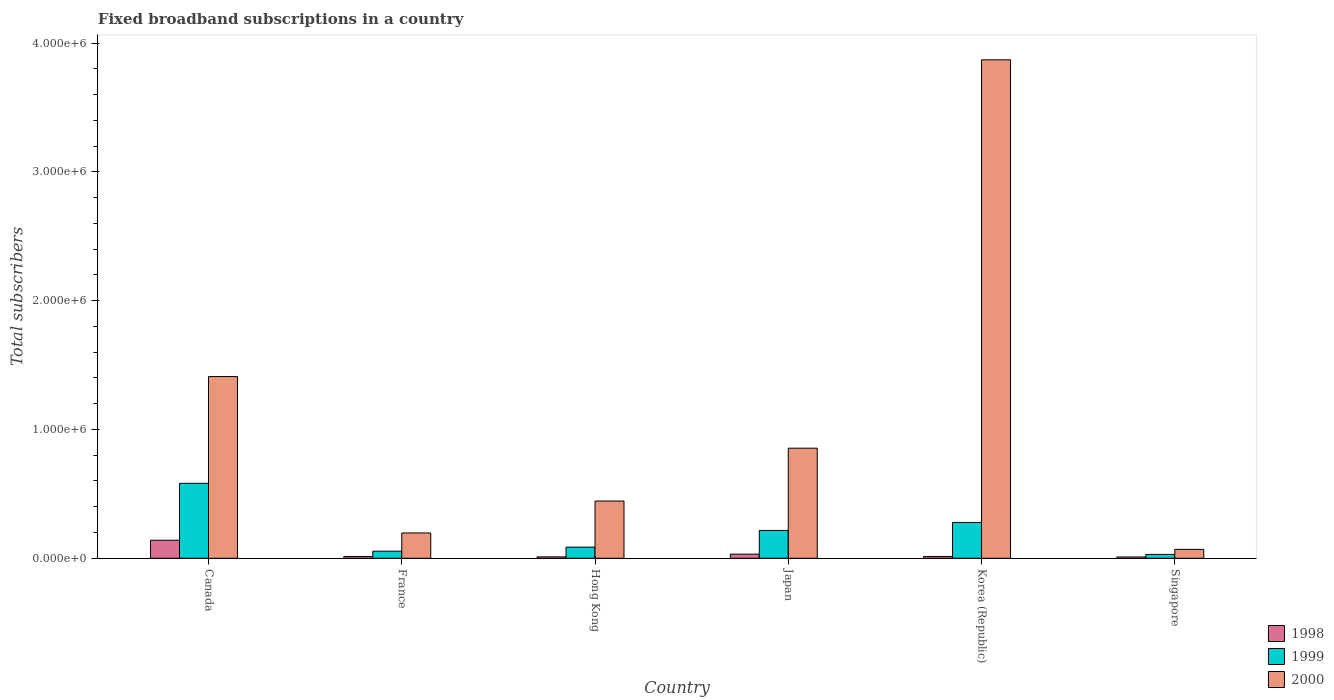How many groups of bars are there?
Your response must be concise. 6. Are the number of bars per tick equal to the number of legend labels?
Offer a terse response. Yes. Are the number of bars on each tick of the X-axis equal?
Your answer should be compact. Yes. How many bars are there on the 6th tick from the left?
Provide a short and direct response. 3. How many bars are there on the 4th tick from the right?
Provide a short and direct response. 3. What is the label of the 3rd group of bars from the left?
Offer a terse response. Hong Kong. What is the number of broadband subscriptions in 2000 in Korea (Republic)?
Offer a terse response. 3.87e+06. Across all countries, what is the maximum number of broadband subscriptions in 1999?
Keep it short and to the point. 5.82e+05. In which country was the number of broadband subscriptions in 2000 minimum?
Ensure brevity in your answer.  Singapore. What is the total number of broadband subscriptions in 1998 in the graph?
Ensure brevity in your answer.  2.20e+05. What is the difference between the number of broadband subscriptions in 1999 in Canada and that in Korea (Republic)?
Make the answer very short. 3.04e+05. What is the difference between the number of broadband subscriptions in 1999 in France and the number of broadband subscriptions in 1998 in Hong Kong?
Offer a terse response. 4.40e+04. What is the average number of broadband subscriptions in 1998 per country?
Your answer should be very brief. 3.67e+04. What is the difference between the number of broadband subscriptions of/in 1998 and number of broadband subscriptions of/in 2000 in Korea (Republic)?
Provide a succinct answer. -3.86e+06. In how many countries, is the number of broadband subscriptions in 1999 greater than 3400000?
Your answer should be compact. 0. What is the ratio of the number of broadband subscriptions in 1998 in France to that in Japan?
Ensure brevity in your answer.  0.42. Is the number of broadband subscriptions in 1999 in Canada less than that in France?
Provide a short and direct response. No. Is the difference between the number of broadband subscriptions in 1998 in Canada and Korea (Republic) greater than the difference between the number of broadband subscriptions in 2000 in Canada and Korea (Republic)?
Your answer should be compact. Yes. What is the difference between the highest and the second highest number of broadband subscriptions in 2000?
Offer a very short reply. 2.46e+06. What is the difference between the highest and the lowest number of broadband subscriptions in 1999?
Offer a very short reply. 5.52e+05. In how many countries, is the number of broadband subscriptions in 2000 greater than the average number of broadband subscriptions in 2000 taken over all countries?
Provide a short and direct response. 2. What does the 1st bar from the left in Singapore represents?
Offer a terse response. 1998. Are the values on the major ticks of Y-axis written in scientific E-notation?
Your response must be concise. Yes. Does the graph contain any zero values?
Your answer should be very brief. No. Does the graph contain grids?
Provide a short and direct response. No. How many legend labels are there?
Your answer should be very brief. 3. How are the legend labels stacked?
Keep it short and to the point. Vertical. What is the title of the graph?
Keep it short and to the point. Fixed broadband subscriptions in a country. What is the label or title of the Y-axis?
Offer a very short reply. Total subscribers. What is the Total subscribers of 1999 in Canada?
Your response must be concise. 5.82e+05. What is the Total subscribers of 2000 in Canada?
Your response must be concise. 1.41e+06. What is the Total subscribers of 1998 in France?
Make the answer very short. 1.35e+04. What is the Total subscribers in 1999 in France?
Offer a terse response. 5.50e+04. What is the Total subscribers in 2000 in France?
Your answer should be compact. 1.97e+05. What is the Total subscribers in 1998 in Hong Kong?
Your answer should be compact. 1.10e+04. What is the Total subscribers in 1999 in Hong Kong?
Offer a terse response. 8.65e+04. What is the Total subscribers in 2000 in Hong Kong?
Ensure brevity in your answer.  4.44e+05. What is the Total subscribers in 1998 in Japan?
Provide a succinct answer. 3.20e+04. What is the Total subscribers of 1999 in Japan?
Your answer should be very brief. 2.16e+05. What is the Total subscribers in 2000 in Japan?
Offer a very short reply. 8.55e+05. What is the Total subscribers of 1998 in Korea (Republic)?
Offer a very short reply. 1.40e+04. What is the Total subscribers in 1999 in Korea (Republic)?
Give a very brief answer. 2.78e+05. What is the Total subscribers of 2000 in Korea (Republic)?
Keep it short and to the point. 3.87e+06. What is the Total subscribers of 1999 in Singapore?
Your answer should be very brief. 3.00e+04. What is the Total subscribers in 2000 in Singapore?
Keep it short and to the point. 6.90e+04. Across all countries, what is the maximum Total subscribers of 1998?
Provide a short and direct response. 1.40e+05. Across all countries, what is the maximum Total subscribers of 1999?
Provide a short and direct response. 5.82e+05. Across all countries, what is the maximum Total subscribers in 2000?
Make the answer very short. 3.87e+06. Across all countries, what is the minimum Total subscribers of 2000?
Ensure brevity in your answer.  6.90e+04. What is the total Total subscribers of 1998 in the graph?
Provide a succinct answer. 2.20e+05. What is the total Total subscribers in 1999 in the graph?
Offer a very short reply. 1.25e+06. What is the total Total subscribers of 2000 in the graph?
Your answer should be very brief. 6.85e+06. What is the difference between the Total subscribers of 1998 in Canada and that in France?
Give a very brief answer. 1.27e+05. What is the difference between the Total subscribers of 1999 in Canada and that in France?
Give a very brief answer. 5.27e+05. What is the difference between the Total subscribers in 2000 in Canada and that in France?
Ensure brevity in your answer.  1.21e+06. What is the difference between the Total subscribers of 1998 in Canada and that in Hong Kong?
Provide a succinct answer. 1.29e+05. What is the difference between the Total subscribers of 1999 in Canada and that in Hong Kong?
Provide a short and direct response. 4.96e+05. What is the difference between the Total subscribers of 2000 in Canada and that in Hong Kong?
Your answer should be very brief. 9.66e+05. What is the difference between the Total subscribers in 1998 in Canada and that in Japan?
Provide a short and direct response. 1.08e+05. What is the difference between the Total subscribers of 1999 in Canada and that in Japan?
Give a very brief answer. 3.66e+05. What is the difference between the Total subscribers of 2000 in Canada and that in Japan?
Keep it short and to the point. 5.56e+05. What is the difference between the Total subscribers of 1998 in Canada and that in Korea (Republic)?
Your response must be concise. 1.26e+05. What is the difference between the Total subscribers in 1999 in Canada and that in Korea (Republic)?
Provide a short and direct response. 3.04e+05. What is the difference between the Total subscribers in 2000 in Canada and that in Korea (Republic)?
Your response must be concise. -2.46e+06. What is the difference between the Total subscribers of 1999 in Canada and that in Singapore?
Offer a very short reply. 5.52e+05. What is the difference between the Total subscribers of 2000 in Canada and that in Singapore?
Keep it short and to the point. 1.34e+06. What is the difference between the Total subscribers of 1998 in France and that in Hong Kong?
Keep it short and to the point. 2464. What is the difference between the Total subscribers in 1999 in France and that in Hong Kong?
Provide a short and direct response. -3.15e+04. What is the difference between the Total subscribers in 2000 in France and that in Hong Kong?
Your answer should be very brief. -2.48e+05. What is the difference between the Total subscribers of 1998 in France and that in Japan?
Provide a succinct answer. -1.85e+04. What is the difference between the Total subscribers in 1999 in France and that in Japan?
Make the answer very short. -1.61e+05. What is the difference between the Total subscribers in 2000 in France and that in Japan?
Offer a very short reply. -6.58e+05. What is the difference between the Total subscribers of 1998 in France and that in Korea (Republic)?
Your answer should be very brief. -536. What is the difference between the Total subscribers of 1999 in France and that in Korea (Republic)?
Provide a short and direct response. -2.23e+05. What is the difference between the Total subscribers in 2000 in France and that in Korea (Republic)?
Offer a terse response. -3.67e+06. What is the difference between the Total subscribers in 1998 in France and that in Singapore?
Your response must be concise. 3464. What is the difference between the Total subscribers of 1999 in France and that in Singapore?
Make the answer very short. 2.50e+04. What is the difference between the Total subscribers in 2000 in France and that in Singapore?
Give a very brief answer. 1.28e+05. What is the difference between the Total subscribers in 1998 in Hong Kong and that in Japan?
Give a very brief answer. -2.10e+04. What is the difference between the Total subscribers in 1999 in Hong Kong and that in Japan?
Your response must be concise. -1.30e+05. What is the difference between the Total subscribers in 2000 in Hong Kong and that in Japan?
Offer a terse response. -4.10e+05. What is the difference between the Total subscribers in 1998 in Hong Kong and that in Korea (Republic)?
Provide a short and direct response. -3000. What is the difference between the Total subscribers of 1999 in Hong Kong and that in Korea (Republic)?
Your answer should be very brief. -1.92e+05. What is the difference between the Total subscribers in 2000 in Hong Kong and that in Korea (Republic)?
Your answer should be compact. -3.43e+06. What is the difference between the Total subscribers in 1998 in Hong Kong and that in Singapore?
Provide a short and direct response. 1000. What is the difference between the Total subscribers in 1999 in Hong Kong and that in Singapore?
Give a very brief answer. 5.65e+04. What is the difference between the Total subscribers in 2000 in Hong Kong and that in Singapore?
Your answer should be compact. 3.75e+05. What is the difference between the Total subscribers in 1998 in Japan and that in Korea (Republic)?
Provide a succinct answer. 1.80e+04. What is the difference between the Total subscribers of 1999 in Japan and that in Korea (Republic)?
Your answer should be very brief. -6.20e+04. What is the difference between the Total subscribers of 2000 in Japan and that in Korea (Republic)?
Give a very brief answer. -3.02e+06. What is the difference between the Total subscribers of 1998 in Japan and that in Singapore?
Your response must be concise. 2.20e+04. What is the difference between the Total subscribers in 1999 in Japan and that in Singapore?
Your response must be concise. 1.86e+05. What is the difference between the Total subscribers of 2000 in Japan and that in Singapore?
Your answer should be very brief. 7.86e+05. What is the difference between the Total subscribers in 1998 in Korea (Republic) and that in Singapore?
Your response must be concise. 4000. What is the difference between the Total subscribers of 1999 in Korea (Republic) and that in Singapore?
Provide a short and direct response. 2.48e+05. What is the difference between the Total subscribers in 2000 in Korea (Republic) and that in Singapore?
Provide a succinct answer. 3.80e+06. What is the difference between the Total subscribers in 1998 in Canada and the Total subscribers in 1999 in France?
Keep it short and to the point. 8.50e+04. What is the difference between the Total subscribers in 1998 in Canada and the Total subscribers in 2000 in France?
Give a very brief answer. -5.66e+04. What is the difference between the Total subscribers of 1999 in Canada and the Total subscribers of 2000 in France?
Offer a very short reply. 3.85e+05. What is the difference between the Total subscribers in 1998 in Canada and the Total subscribers in 1999 in Hong Kong?
Provide a succinct answer. 5.35e+04. What is the difference between the Total subscribers of 1998 in Canada and the Total subscribers of 2000 in Hong Kong?
Give a very brief answer. -3.04e+05. What is the difference between the Total subscribers of 1999 in Canada and the Total subscribers of 2000 in Hong Kong?
Keep it short and to the point. 1.38e+05. What is the difference between the Total subscribers in 1998 in Canada and the Total subscribers in 1999 in Japan?
Make the answer very short. -7.60e+04. What is the difference between the Total subscribers in 1998 in Canada and the Total subscribers in 2000 in Japan?
Your response must be concise. -7.15e+05. What is the difference between the Total subscribers of 1999 in Canada and the Total subscribers of 2000 in Japan?
Your answer should be compact. -2.73e+05. What is the difference between the Total subscribers in 1998 in Canada and the Total subscribers in 1999 in Korea (Republic)?
Your answer should be compact. -1.38e+05. What is the difference between the Total subscribers of 1998 in Canada and the Total subscribers of 2000 in Korea (Republic)?
Keep it short and to the point. -3.73e+06. What is the difference between the Total subscribers of 1999 in Canada and the Total subscribers of 2000 in Korea (Republic)?
Your answer should be very brief. -3.29e+06. What is the difference between the Total subscribers of 1998 in Canada and the Total subscribers of 2000 in Singapore?
Ensure brevity in your answer.  7.10e+04. What is the difference between the Total subscribers of 1999 in Canada and the Total subscribers of 2000 in Singapore?
Offer a terse response. 5.13e+05. What is the difference between the Total subscribers in 1998 in France and the Total subscribers in 1999 in Hong Kong?
Provide a succinct answer. -7.30e+04. What is the difference between the Total subscribers in 1998 in France and the Total subscribers in 2000 in Hong Kong?
Offer a terse response. -4.31e+05. What is the difference between the Total subscribers in 1999 in France and the Total subscribers in 2000 in Hong Kong?
Make the answer very short. -3.89e+05. What is the difference between the Total subscribers of 1998 in France and the Total subscribers of 1999 in Japan?
Provide a short and direct response. -2.03e+05. What is the difference between the Total subscribers in 1998 in France and the Total subscribers in 2000 in Japan?
Provide a short and direct response. -8.41e+05. What is the difference between the Total subscribers in 1999 in France and the Total subscribers in 2000 in Japan?
Make the answer very short. -8.00e+05. What is the difference between the Total subscribers in 1998 in France and the Total subscribers in 1999 in Korea (Republic)?
Your answer should be compact. -2.65e+05. What is the difference between the Total subscribers in 1998 in France and the Total subscribers in 2000 in Korea (Republic)?
Keep it short and to the point. -3.86e+06. What is the difference between the Total subscribers in 1999 in France and the Total subscribers in 2000 in Korea (Republic)?
Make the answer very short. -3.82e+06. What is the difference between the Total subscribers of 1998 in France and the Total subscribers of 1999 in Singapore?
Provide a succinct answer. -1.65e+04. What is the difference between the Total subscribers in 1998 in France and the Total subscribers in 2000 in Singapore?
Your response must be concise. -5.55e+04. What is the difference between the Total subscribers of 1999 in France and the Total subscribers of 2000 in Singapore?
Your response must be concise. -1.40e+04. What is the difference between the Total subscribers in 1998 in Hong Kong and the Total subscribers in 1999 in Japan?
Offer a terse response. -2.05e+05. What is the difference between the Total subscribers in 1998 in Hong Kong and the Total subscribers in 2000 in Japan?
Your answer should be very brief. -8.44e+05. What is the difference between the Total subscribers of 1999 in Hong Kong and the Total subscribers of 2000 in Japan?
Make the answer very short. -7.68e+05. What is the difference between the Total subscribers of 1998 in Hong Kong and the Total subscribers of 1999 in Korea (Republic)?
Provide a succinct answer. -2.67e+05. What is the difference between the Total subscribers in 1998 in Hong Kong and the Total subscribers in 2000 in Korea (Republic)?
Your response must be concise. -3.86e+06. What is the difference between the Total subscribers in 1999 in Hong Kong and the Total subscribers in 2000 in Korea (Republic)?
Your answer should be compact. -3.78e+06. What is the difference between the Total subscribers in 1998 in Hong Kong and the Total subscribers in 1999 in Singapore?
Give a very brief answer. -1.90e+04. What is the difference between the Total subscribers of 1998 in Hong Kong and the Total subscribers of 2000 in Singapore?
Provide a short and direct response. -5.80e+04. What is the difference between the Total subscribers of 1999 in Hong Kong and the Total subscribers of 2000 in Singapore?
Your response must be concise. 1.75e+04. What is the difference between the Total subscribers of 1998 in Japan and the Total subscribers of 1999 in Korea (Republic)?
Provide a short and direct response. -2.46e+05. What is the difference between the Total subscribers in 1998 in Japan and the Total subscribers in 2000 in Korea (Republic)?
Offer a terse response. -3.84e+06. What is the difference between the Total subscribers in 1999 in Japan and the Total subscribers in 2000 in Korea (Republic)?
Your answer should be very brief. -3.65e+06. What is the difference between the Total subscribers in 1998 in Japan and the Total subscribers in 1999 in Singapore?
Provide a succinct answer. 2000. What is the difference between the Total subscribers in 1998 in Japan and the Total subscribers in 2000 in Singapore?
Provide a succinct answer. -3.70e+04. What is the difference between the Total subscribers in 1999 in Japan and the Total subscribers in 2000 in Singapore?
Make the answer very short. 1.47e+05. What is the difference between the Total subscribers in 1998 in Korea (Republic) and the Total subscribers in 1999 in Singapore?
Provide a succinct answer. -1.60e+04. What is the difference between the Total subscribers of 1998 in Korea (Republic) and the Total subscribers of 2000 in Singapore?
Ensure brevity in your answer.  -5.50e+04. What is the difference between the Total subscribers of 1999 in Korea (Republic) and the Total subscribers of 2000 in Singapore?
Offer a terse response. 2.09e+05. What is the average Total subscribers in 1998 per country?
Provide a succinct answer. 3.67e+04. What is the average Total subscribers of 1999 per country?
Give a very brief answer. 2.08e+05. What is the average Total subscribers of 2000 per country?
Provide a short and direct response. 1.14e+06. What is the difference between the Total subscribers in 1998 and Total subscribers in 1999 in Canada?
Your response must be concise. -4.42e+05. What is the difference between the Total subscribers in 1998 and Total subscribers in 2000 in Canada?
Your answer should be compact. -1.27e+06. What is the difference between the Total subscribers in 1999 and Total subscribers in 2000 in Canada?
Keep it short and to the point. -8.29e+05. What is the difference between the Total subscribers in 1998 and Total subscribers in 1999 in France?
Give a very brief answer. -4.15e+04. What is the difference between the Total subscribers in 1998 and Total subscribers in 2000 in France?
Provide a succinct answer. -1.83e+05. What is the difference between the Total subscribers in 1999 and Total subscribers in 2000 in France?
Offer a terse response. -1.42e+05. What is the difference between the Total subscribers in 1998 and Total subscribers in 1999 in Hong Kong?
Your response must be concise. -7.55e+04. What is the difference between the Total subscribers of 1998 and Total subscribers of 2000 in Hong Kong?
Provide a succinct answer. -4.33e+05. What is the difference between the Total subscribers of 1999 and Total subscribers of 2000 in Hong Kong?
Offer a terse response. -3.58e+05. What is the difference between the Total subscribers of 1998 and Total subscribers of 1999 in Japan?
Keep it short and to the point. -1.84e+05. What is the difference between the Total subscribers of 1998 and Total subscribers of 2000 in Japan?
Give a very brief answer. -8.23e+05. What is the difference between the Total subscribers in 1999 and Total subscribers in 2000 in Japan?
Offer a very short reply. -6.39e+05. What is the difference between the Total subscribers in 1998 and Total subscribers in 1999 in Korea (Republic)?
Keep it short and to the point. -2.64e+05. What is the difference between the Total subscribers of 1998 and Total subscribers of 2000 in Korea (Republic)?
Offer a very short reply. -3.86e+06. What is the difference between the Total subscribers of 1999 and Total subscribers of 2000 in Korea (Republic)?
Offer a very short reply. -3.59e+06. What is the difference between the Total subscribers of 1998 and Total subscribers of 2000 in Singapore?
Your response must be concise. -5.90e+04. What is the difference between the Total subscribers of 1999 and Total subscribers of 2000 in Singapore?
Offer a very short reply. -3.90e+04. What is the ratio of the Total subscribers in 1998 in Canada to that in France?
Your answer should be compact. 10.4. What is the ratio of the Total subscribers in 1999 in Canada to that in France?
Your response must be concise. 10.58. What is the ratio of the Total subscribers in 2000 in Canada to that in France?
Ensure brevity in your answer.  7.18. What is the ratio of the Total subscribers in 1998 in Canada to that in Hong Kong?
Ensure brevity in your answer.  12.73. What is the ratio of the Total subscribers of 1999 in Canada to that in Hong Kong?
Provide a short and direct response. 6.73. What is the ratio of the Total subscribers in 2000 in Canada to that in Hong Kong?
Your response must be concise. 3.17. What is the ratio of the Total subscribers in 1998 in Canada to that in Japan?
Offer a very short reply. 4.38. What is the ratio of the Total subscribers in 1999 in Canada to that in Japan?
Your response must be concise. 2.69. What is the ratio of the Total subscribers in 2000 in Canada to that in Japan?
Provide a short and direct response. 1.65. What is the ratio of the Total subscribers in 1998 in Canada to that in Korea (Republic)?
Provide a succinct answer. 10. What is the ratio of the Total subscribers in 1999 in Canada to that in Korea (Republic)?
Offer a terse response. 2.09. What is the ratio of the Total subscribers of 2000 in Canada to that in Korea (Republic)?
Offer a terse response. 0.36. What is the ratio of the Total subscribers of 1999 in Canada to that in Singapore?
Provide a short and direct response. 19.4. What is the ratio of the Total subscribers in 2000 in Canada to that in Singapore?
Give a very brief answer. 20.45. What is the ratio of the Total subscribers of 1998 in France to that in Hong Kong?
Offer a terse response. 1.22. What is the ratio of the Total subscribers of 1999 in France to that in Hong Kong?
Make the answer very short. 0.64. What is the ratio of the Total subscribers of 2000 in France to that in Hong Kong?
Your answer should be very brief. 0.44. What is the ratio of the Total subscribers in 1998 in France to that in Japan?
Ensure brevity in your answer.  0.42. What is the ratio of the Total subscribers in 1999 in France to that in Japan?
Offer a terse response. 0.25. What is the ratio of the Total subscribers in 2000 in France to that in Japan?
Offer a very short reply. 0.23. What is the ratio of the Total subscribers in 1998 in France to that in Korea (Republic)?
Your answer should be very brief. 0.96. What is the ratio of the Total subscribers of 1999 in France to that in Korea (Republic)?
Keep it short and to the point. 0.2. What is the ratio of the Total subscribers in 2000 in France to that in Korea (Republic)?
Keep it short and to the point. 0.05. What is the ratio of the Total subscribers in 1998 in France to that in Singapore?
Your answer should be very brief. 1.35. What is the ratio of the Total subscribers of 1999 in France to that in Singapore?
Your response must be concise. 1.83. What is the ratio of the Total subscribers of 2000 in France to that in Singapore?
Your response must be concise. 2.85. What is the ratio of the Total subscribers of 1998 in Hong Kong to that in Japan?
Make the answer very short. 0.34. What is the ratio of the Total subscribers of 1999 in Hong Kong to that in Japan?
Keep it short and to the point. 0.4. What is the ratio of the Total subscribers in 2000 in Hong Kong to that in Japan?
Provide a succinct answer. 0.52. What is the ratio of the Total subscribers in 1998 in Hong Kong to that in Korea (Republic)?
Ensure brevity in your answer.  0.79. What is the ratio of the Total subscribers of 1999 in Hong Kong to that in Korea (Republic)?
Ensure brevity in your answer.  0.31. What is the ratio of the Total subscribers of 2000 in Hong Kong to that in Korea (Republic)?
Provide a succinct answer. 0.11. What is the ratio of the Total subscribers of 1998 in Hong Kong to that in Singapore?
Give a very brief answer. 1.1. What is the ratio of the Total subscribers of 1999 in Hong Kong to that in Singapore?
Give a very brief answer. 2.88. What is the ratio of the Total subscribers of 2000 in Hong Kong to that in Singapore?
Offer a terse response. 6.44. What is the ratio of the Total subscribers in 1998 in Japan to that in Korea (Republic)?
Provide a succinct answer. 2.29. What is the ratio of the Total subscribers of 1999 in Japan to that in Korea (Republic)?
Offer a terse response. 0.78. What is the ratio of the Total subscribers of 2000 in Japan to that in Korea (Republic)?
Make the answer very short. 0.22. What is the ratio of the Total subscribers of 1999 in Japan to that in Singapore?
Ensure brevity in your answer.  7.2. What is the ratio of the Total subscribers in 2000 in Japan to that in Singapore?
Give a very brief answer. 12.39. What is the ratio of the Total subscribers in 1998 in Korea (Republic) to that in Singapore?
Your response must be concise. 1.4. What is the ratio of the Total subscribers in 1999 in Korea (Republic) to that in Singapore?
Offer a terse response. 9.27. What is the ratio of the Total subscribers of 2000 in Korea (Republic) to that in Singapore?
Your response must be concise. 56.09. What is the difference between the highest and the second highest Total subscribers of 1998?
Offer a terse response. 1.08e+05. What is the difference between the highest and the second highest Total subscribers in 1999?
Make the answer very short. 3.04e+05. What is the difference between the highest and the second highest Total subscribers of 2000?
Keep it short and to the point. 2.46e+06. What is the difference between the highest and the lowest Total subscribers in 1999?
Ensure brevity in your answer.  5.52e+05. What is the difference between the highest and the lowest Total subscribers of 2000?
Keep it short and to the point. 3.80e+06. 